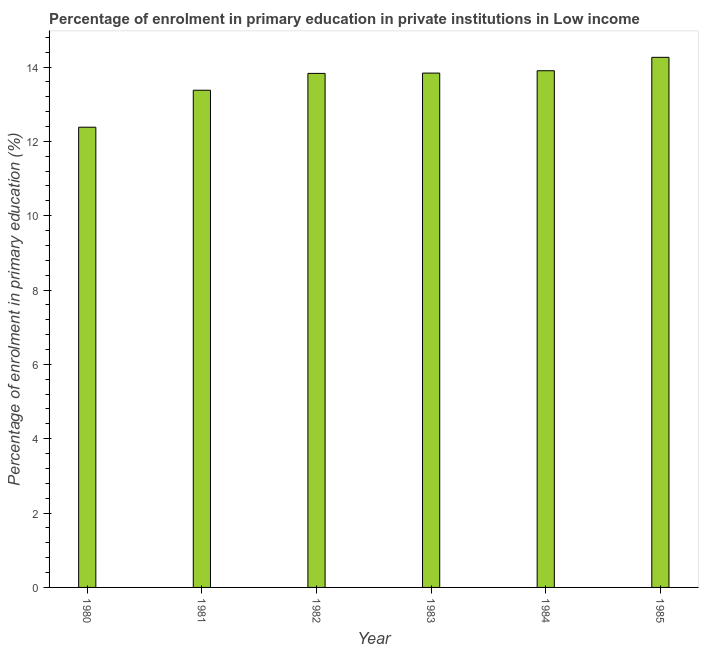What is the title of the graph?
Keep it short and to the point. Percentage of enrolment in primary education in private institutions in Low income. What is the label or title of the X-axis?
Your answer should be very brief. Year. What is the label or title of the Y-axis?
Make the answer very short. Percentage of enrolment in primary education (%). What is the enrolment percentage in primary education in 1983?
Make the answer very short. 13.84. Across all years, what is the maximum enrolment percentage in primary education?
Make the answer very short. 14.26. Across all years, what is the minimum enrolment percentage in primary education?
Your answer should be very brief. 12.38. In which year was the enrolment percentage in primary education maximum?
Offer a terse response. 1985. In which year was the enrolment percentage in primary education minimum?
Your response must be concise. 1980. What is the sum of the enrolment percentage in primary education?
Offer a terse response. 81.58. What is the difference between the enrolment percentage in primary education in 1980 and 1985?
Offer a terse response. -1.88. What is the average enrolment percentage in primary education per year?
Your response must be concise. 13.6. What is the median enrolment percentage in primary education?
Your answer should be compact. 13.83. What is the ratio of the enrolment percentage in primary education in 1982 to that in 1983?
Provide a short and direct response. 1. Is the difference between the enrolment percentage in primary education in 1981 and 1985 greater than the difference between any two years?
Ensure brevity in your answer.  No. What is the difference between the highest and the second highest enrolment percentage in primary education?
Make the answer very short. 0.36. What is the difference between the highest and the lowest enrolment percentage in primary education?
Give a very brief answer. 1.88. In how many years, is the enrolment percentage in primary education greater than the average enrolment percentage in primary education taken over all years?
Ensure brevity in your answer.  4. How many bars are there?
Your answer should be very brief. 6. What is the difference between two consecutive major ticks on the Y-axis?
Make the answer very short. 2. What is the Percentage of enrolment in primary education (%) of 1980?
Your answer should be very brief. 12.38. What is the Percentage of enrolment in primary education (%) of 1981?
Provide a short and direct response. 13.38. What is the Percentage of enrolment in primary education (%) of 1982?
Keep it short and to the point. 13.83. What is the Percentage of enrolment in primary education (%) in 1983?
Make the answer very short. 13.84. What is the Percentage of enrolment in primary education (%) in 1984?
Ensure brevity in your answer.  13.9. What is the Percentage of enrolment in primary education (%) of 1985?
Make the answer very short. 14.26. What is the difference between the Percentage of enrolment in primary education (%) in 1980 and 1981?
Give a very brief answer. -0.99. What is the difference between the Percentage of enrolment in primary education (%) in 1980 and 1982?
Give a very brief answer. -1.45. What is the difference between the Percentage of enrolment in primary education (%) in 1980 and 1983?
Keep it short and to the point. -1.46. What is the difference between the Percentage of enrolment in primary education (%) in 1980 and 1984?
Your response must be concise. -1.52. What is the difference between the Percentage of enrolment in primary education (%) in 1980 and 1985?
Keep it short and to the point. -1.88. What is the difference between the Percentage of enrolment in primary education (%) in 1981 and 1982?
Keep it short and to the point. -0.45. What is the difference between the Percentage of enrolment in primary education (%) in 1981 and 1983?
Give a very brief answer. -0.46. What is the difference between the Percentage of enrolment in primary education (%) in 1981 and 1984?
Your answer should be very brief. -0.52. What is the difference between the Percentage of enrolment in primary education (%) in 1981 and 1985?
Make the answer very short. -0.89. What is the difference between the Percentage of enrolment in primary education (%) in 1982 and 1983?
Ensure brevity in your answer.  -0.01. What is the difference between the Percentage of enrolment in primary education (%) in 1982 and 1984?
Give a very brief answer. -0.07. What is the difference between the Percentage of enrolment in primary education (%) in 1982 and 1985?
Provide a succinct answer. -0.43. What is the difference between the Percentage of enrolment in primary education (%) in 1983 and 1984?
Provide a succinct answer. -0.06. What is the difference between the Percentage of enrolment in primary education (%) in 1983 and 1985?
Your answer should be compact. -0.42. What is the difference between the Percentage of enrolment in primary education (%) in 1984 and 1985?
Keep it short and to the point. -0.36. What is the ratio of the Percentage of enrolment in primary education (%) in 1980 to that in 1981?
Your response must be concise. 0.93. What is the ratio of the Percentage of enrolment in primary education (%) in 1980 to that in 1982?
Ensure brevity in your answer.  0.9. What is the ratio of the Percentage of enrolment in primary education (%) in 1980 to that in 1983?
Offer a very short reply. 0.9. What is the ratio of the Percentage of enrolment in primary education (%) in 1980 to that in 1984?
Give a very brief answer. 0.89. What is the ratio of the Percentage of enrolment in primary education (%) in 1980 to that in 1985?
Offer a terse response. 0.87. What is the ratio of the Percentage of enrolment in primary education (%) in 1981 to that in 1983?
Offer a very short reply. 0.97. What is the ratio of the Percentage of enrolment in primary education (%) in 1981 to that in 1984?
Your answer should be compact. 0.96. What is the ratio of the Percentage of enrolment in primary education (%) in 1981 to that in 1985?
Keep it short and to the point. 0.94. What is the ratio of the Percentage of enrolment in primary education (%) in 1982 to that in 1983?
Provide a short and direct response. 1. What is the ratio of the Percentage of enrolment in primary education (%) in 1983 to that in 1985?
Provide a short and direct response. 0.97. What is the ratio of the Percentage of enrolment in primary education (%) in 1984 to that in 1985?
Offer a very short reply. 0.97. 